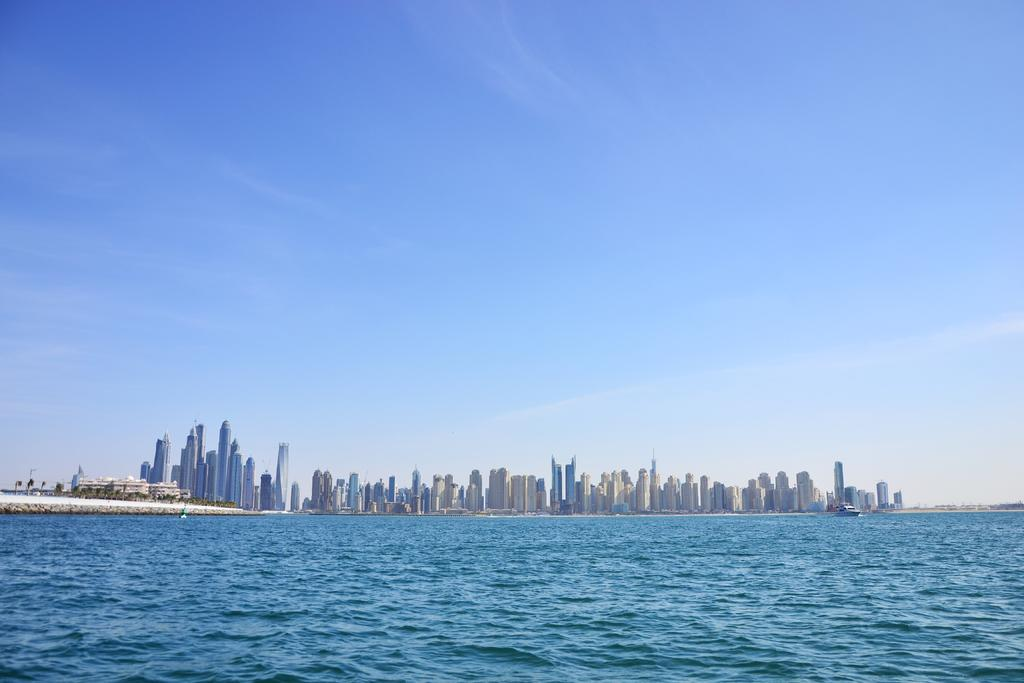What is visible in the image? There is water visible in the image. What can be seen in the distance in the image? There are buildings in the background of the image. How would you describe the sky in the image? The sky is clear in the background of the image. How many coils are present in the water in the image? There are no coils present in the water in the image. 